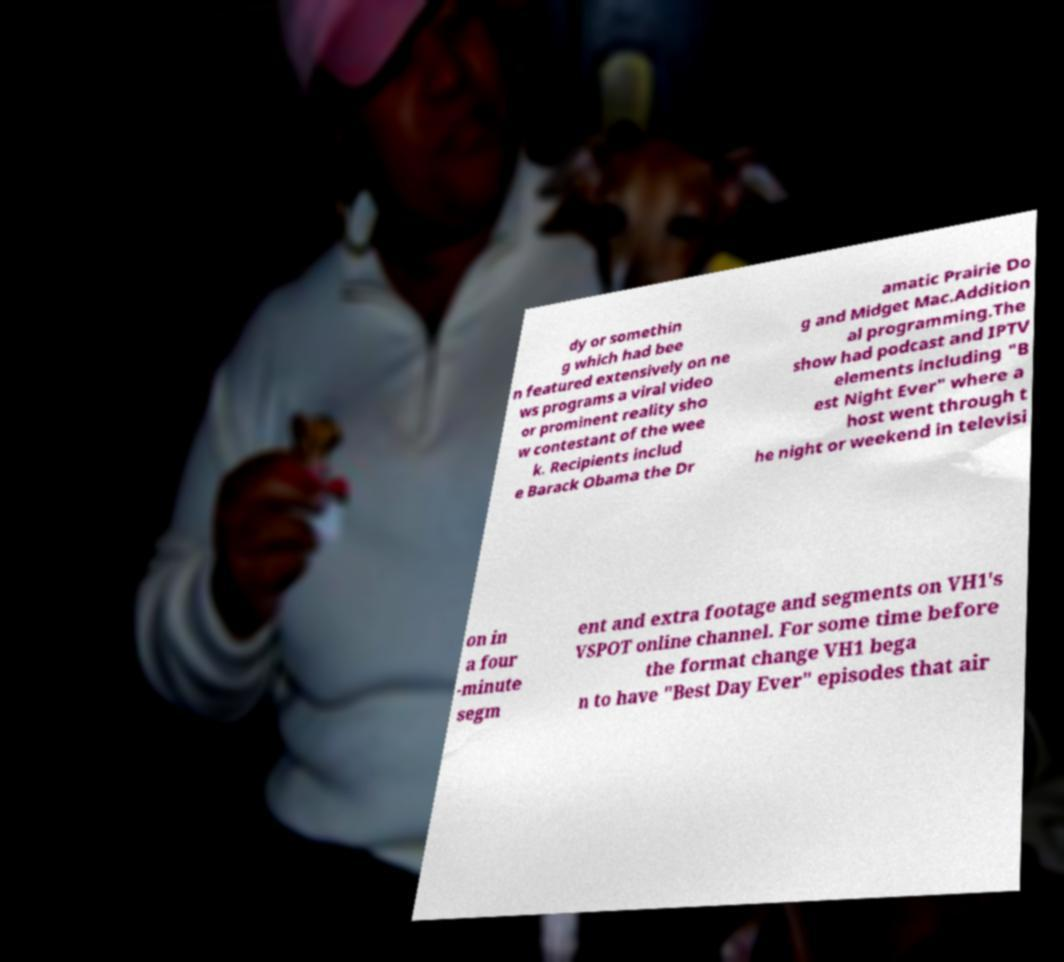Can you read and provide the text displayed in the image?This photo seems to have some interesting text. Can you extract and type it out for me? dy or somethin g which had bee n featured extensively on ne ws programs a viral video or prominent reality sho w contestant of the wee k. Recipients includ e Barack Obama the Dr amatic Prairie Do g and Midget Mac.Addition al programming.The show had podcast and IPTV elements including "B est Night Ever" where a host went through t he night or weekend in televisi on in a four -minute segm ent and extra footage and segments on VH1's VSPOT online channel. For some time before the format change VH1 bega n to have "Best Day Ever" episodes that air 